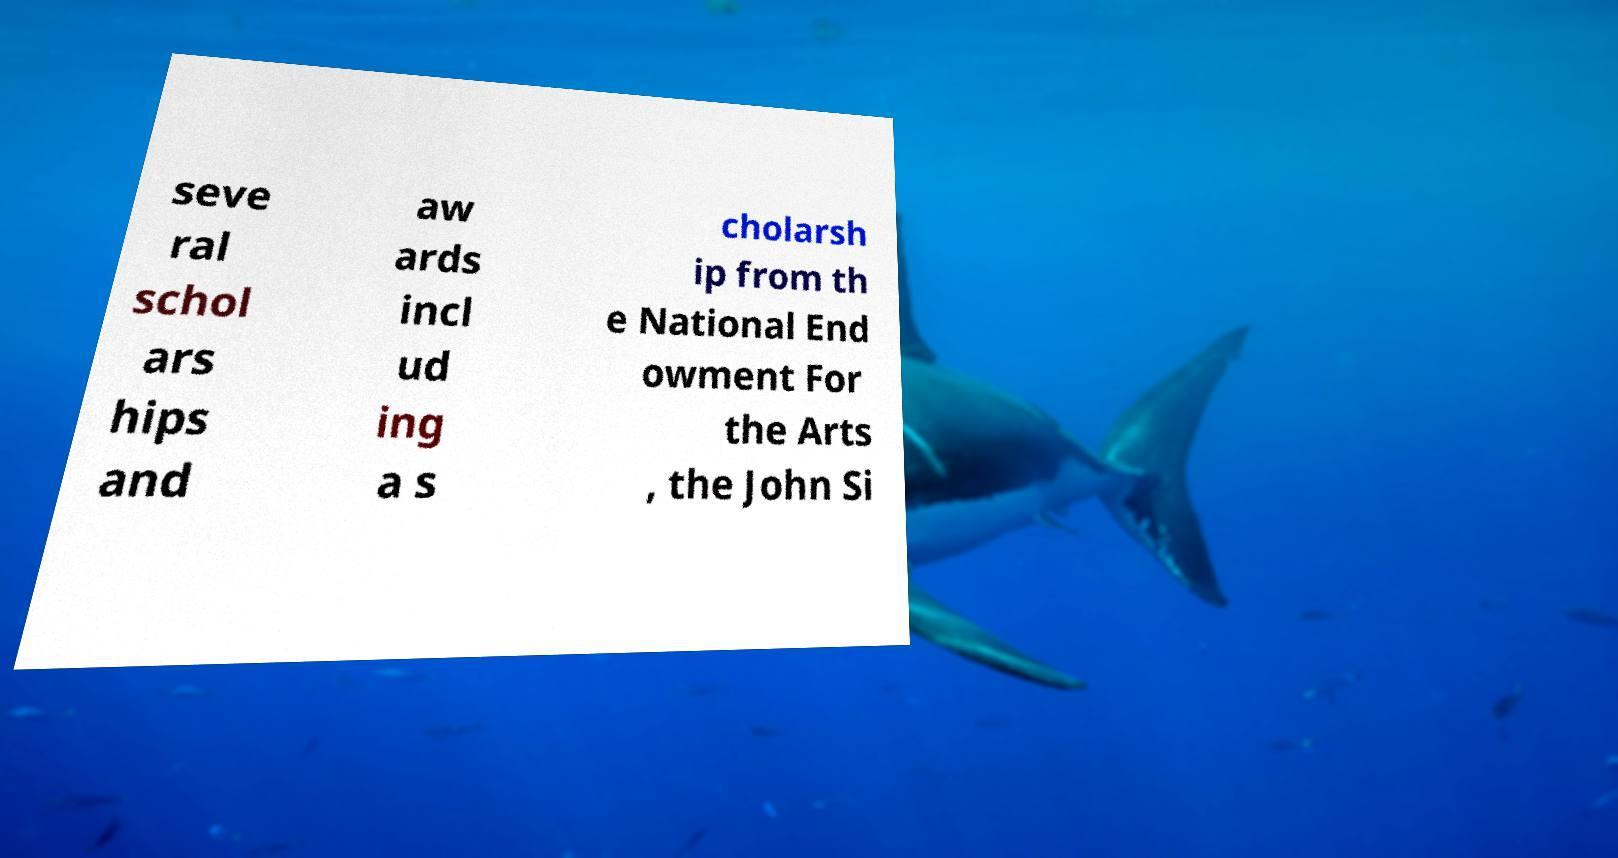Can you read and provide the text displayed in the image?This photo seems to have some interesting text. Can you extract and type it out for me? seve ral schol ars hips and aw ards incl ud ing a s cholarsh ip from th e National End owment For the Arts , the John Si 